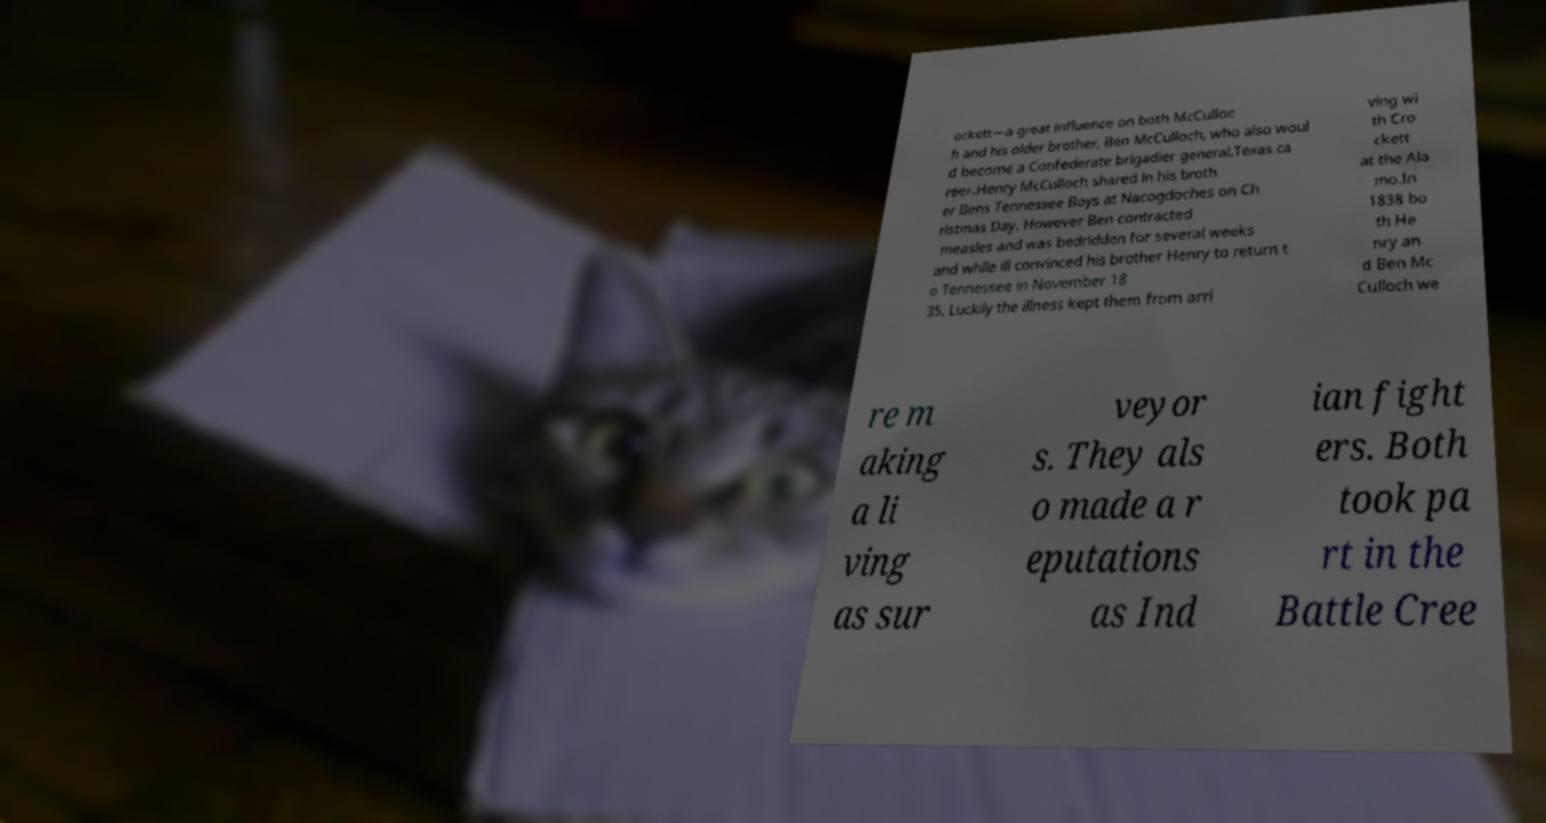Please identify and transcribe the text found in this image. ockett—a great influence on both McCulloc h and his older brother, Ben McCulloch, who also woul d become a Confederate brigadier general.Texas ca reer.Henry McCulloch shared in his broth er Bens Tennessee Boys at Nacogdoches on Ch ristmas Day. However Ben contracted measles and was bedridden for several weeks and while ill convinced his brother Henry to return t o Tennessee in November 18 35. Luckily the illness kept them from arri ving wi th Cro ckett at the Ala mo.In 1838 bo th He nry an d Ben Mc Culloch we re m aking a li ving as sur veyor s. They als o made a r eputations as Ind ian fight ers. Both took pa rt in the Battle Cree 